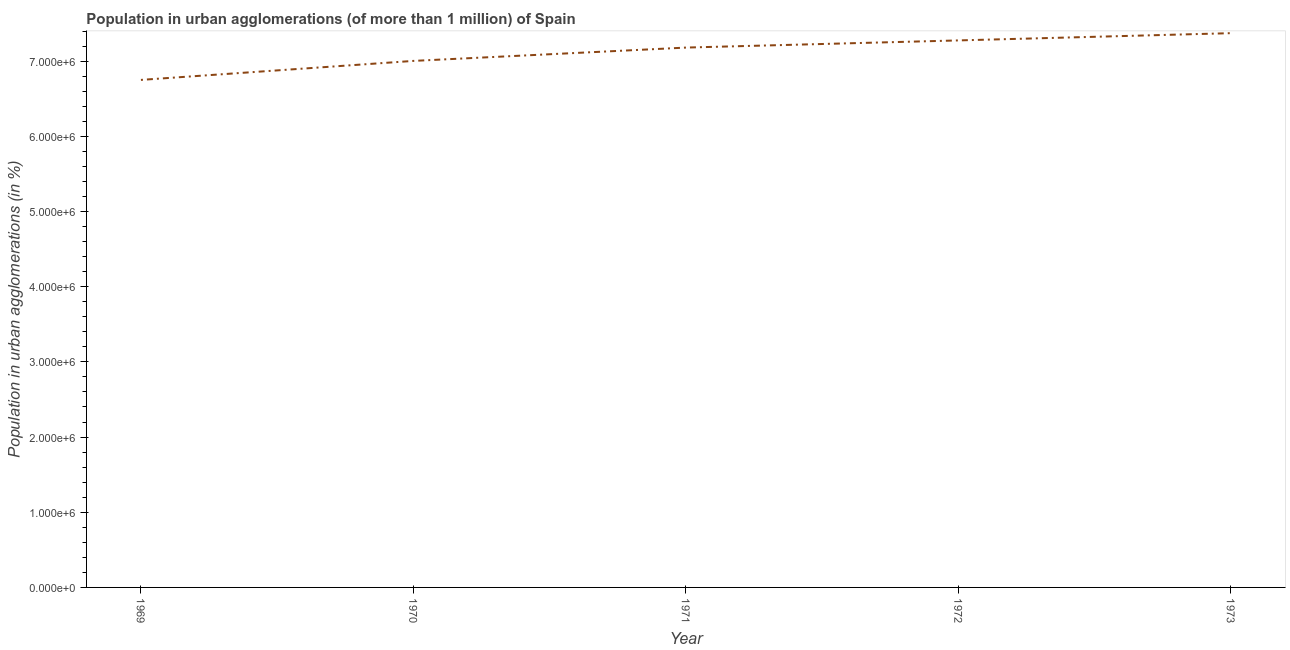What is the population in urban agglomerations in 1969?
Keep it short and to the point. 6.75e+06. Across all years, what is the maximum population in urban agglomerations?
Your response must be concise. 7.37e+06. Across all years, what is the minimum population in urban agglomerations?
Your answer should be very brief. 6.75e+06. In which year was the population in urban agglomerations minimum?
Ensure brevity in your answer.  1969. What is the sum of the population in urban agglomerations?
Your answer should be compact. 3.56e+07. What is the difference between the population in urban agglomerations in 1972 and 1973?
Provide a succinct answer. -9.64e+04. What is the average population in urban agglomerations per year?
Make the answer very short. 7.12e+06. What is the median population in urban agglomerations?
Give a very brief answer. 7.18e+06. In how many years, is the population in urban agglomerations greater than 6800000 %?
Provide a succinct answer. 4. Do a majority of the years between 1971 and 1969 (inclusive) have population in urban agglomerations greater than 4600000 %?
Provide a short and direct response. No. What is the ratio of the population in urban agglomerations in 1971 to that in 1973?
Make the answer very short. 0.97. What is the difference between the highest and the second highest population in urban agglomerations?
Make the answer very short. 9.64e+04. Is the sum of the population in urban agglomerations in 1971 and 1973 greater than the maximum population in urban agglomerations across all years?
Your answer should be very brief. Yes. What is the difference between the highest and the lowest population in urban agglomerations?
Offer a terse response. 6.22e+05. In how many years, is the population in urban agglomerations greater than the average population in urban agglomerations taken over all years?
Offer a terse response. 3. How many lines are there?
Provide a short and direct response. 1. Does the graph contain any zero values?
Make the answer very short. No. What is the title of the graph?
Make the answer very short. Population in urban agglomerations (of more than 1 million) of Spain. What is the label or title of the X-axis?
Offer a terse response. Year. What is the label or title of the Y-axis?
Provide a short and direct response. Population in urban agglomerations (in %). What is the Population in urban agglomerations (in %) of 1969?
Offer a very short reply. 6.75e+06. What is the Population in urban agglomerations (in %) of 1970?
Provide a succinct answer. 7.00e+06. What is the Population in urban agglomerations (in %) in 1971?
Ensure brevity in your answer.  7.18e+06. What is the Population in urban agglomerations (in %) in 1972?
Give a very brief answer. 7.28e+06. What is the Population in urban agglomerations (in %) in 1973?
Ensure brevity in your answer.  7.37e+06. What is the difference between the Population in urban agglomerations (in %) in 1969 and 1970?
Provide a short and direct response. -2.53e+05. What is the difference between the Population in urban agglomerations (in %) in 1969 and 1971?
Ensure brevity in your answer.  -4.30e+05. What is the difference between the Population in urban agglomerations (in %) in 1969 and 1972?
Your answer should be compact. -5.25e+05. What is the difference between the Population in urban agglomerations (in %) in 1969 and 1973?
Provide a succinct answer. -6.22e+05. What is the difference between the Population in urban agglomerations (in %) in 1970 and 1971?
Ensure brevity in your answer.  -1.77e+05. What is the difference between the Population in urban agglomerations (in %) in 1970 and 1972?
Provide a short and direct response. -2.72e+05. What is the difference between the Population in urban agglomerations (in %) in 1970 and 1973?
Give a very brief answer. -3.69e+05. What is the difference between the Population in urban agglomerations (in %) in 1971 and 1972?
Make the answer very short. -9.53e+04. What is the difference between the Population in urban agglomerations (in %) in 1971 and 1973?
Ensure brevity in your answer.  -1.92e+05. What is the difference between the Population in urban agglomerations (in %) in 1972 and 1973?
Your response must be concise. -9.64e+04. What is the ratio of the Population in urban agglomerations (in %) in 1969 to that in 1970?
Ensure brevity in your answer.  0.96. What is the ratio of the Population in urban agglomerations (in %) in 1969 to that in 1972?
Make the answer very short. 0.93. What is the ratio of the Population in urban agglomerations (in %) in 1969 to that in 1973?
Offer a terse response. 0.92. What is the ratio of the Population in urban agglomerations (in %) in 1970 to that in 1971?
Your answer should be very brief. 0.97. What is the ratio of the Population in urban agglomerations (in %) in 1972 to that in 1973?
Your answer should be very brief. 0.99. 